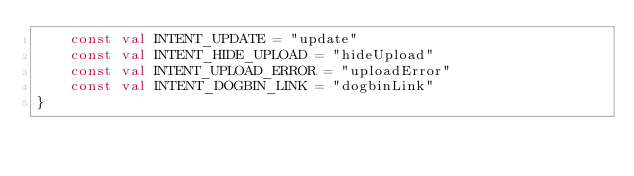<code> <loc_0><loc_0><loc_500><loc_500><_Kotlin_>    const val INTENT_UPDATE = "update"
    const val INTENT_HIDE_UPLOAD = "hideUpload"
    const val INTENT_UPLOAD_ERROR = "uploadError"
    const val INTENT_DOGBIN_LINK = "dogbinLink"
}
</code> 